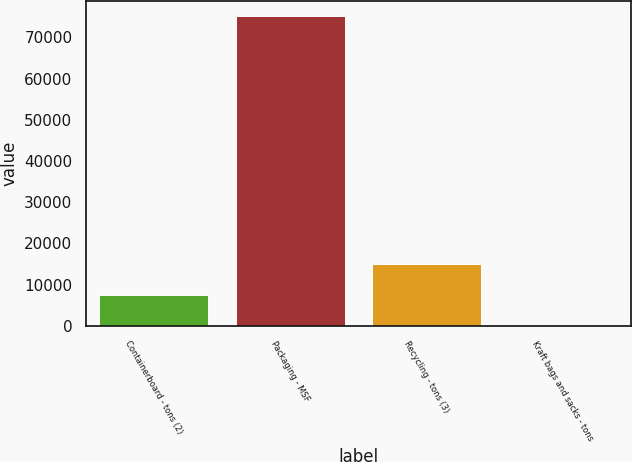Convert chart to OTSL. <chart><loc_0><loc_0><loc_500><loc_500><bar_chart><fcel>Containerboard - tons (2)<fcel>Packaging - MSF<fcel>Recycling - tons (3)<fcel>Kraft bags and sacks - tons<nl><fcel>7593.7<fcel>75100<fcel>15094.4<fcel>93<nl></chart> 